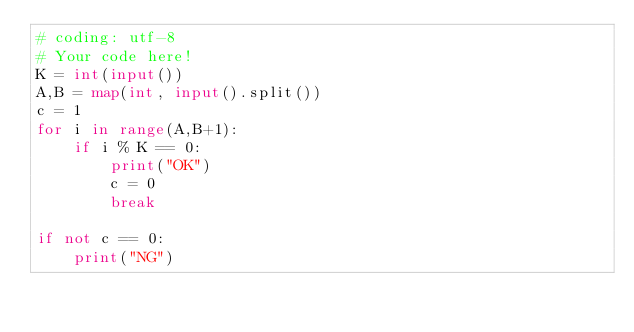<code> <loc_0><loc_0><loc_500><loc_500><_Python_># coding: utf-8
# Your code here!
K = int(input())
A,B = map(int, input().split())
c = 1 
for i in range(A,B+1):
    if i % K == 0: 
        print("OK")
        c = 0
        break

if not c == 0:
    print("NG")
</code> 